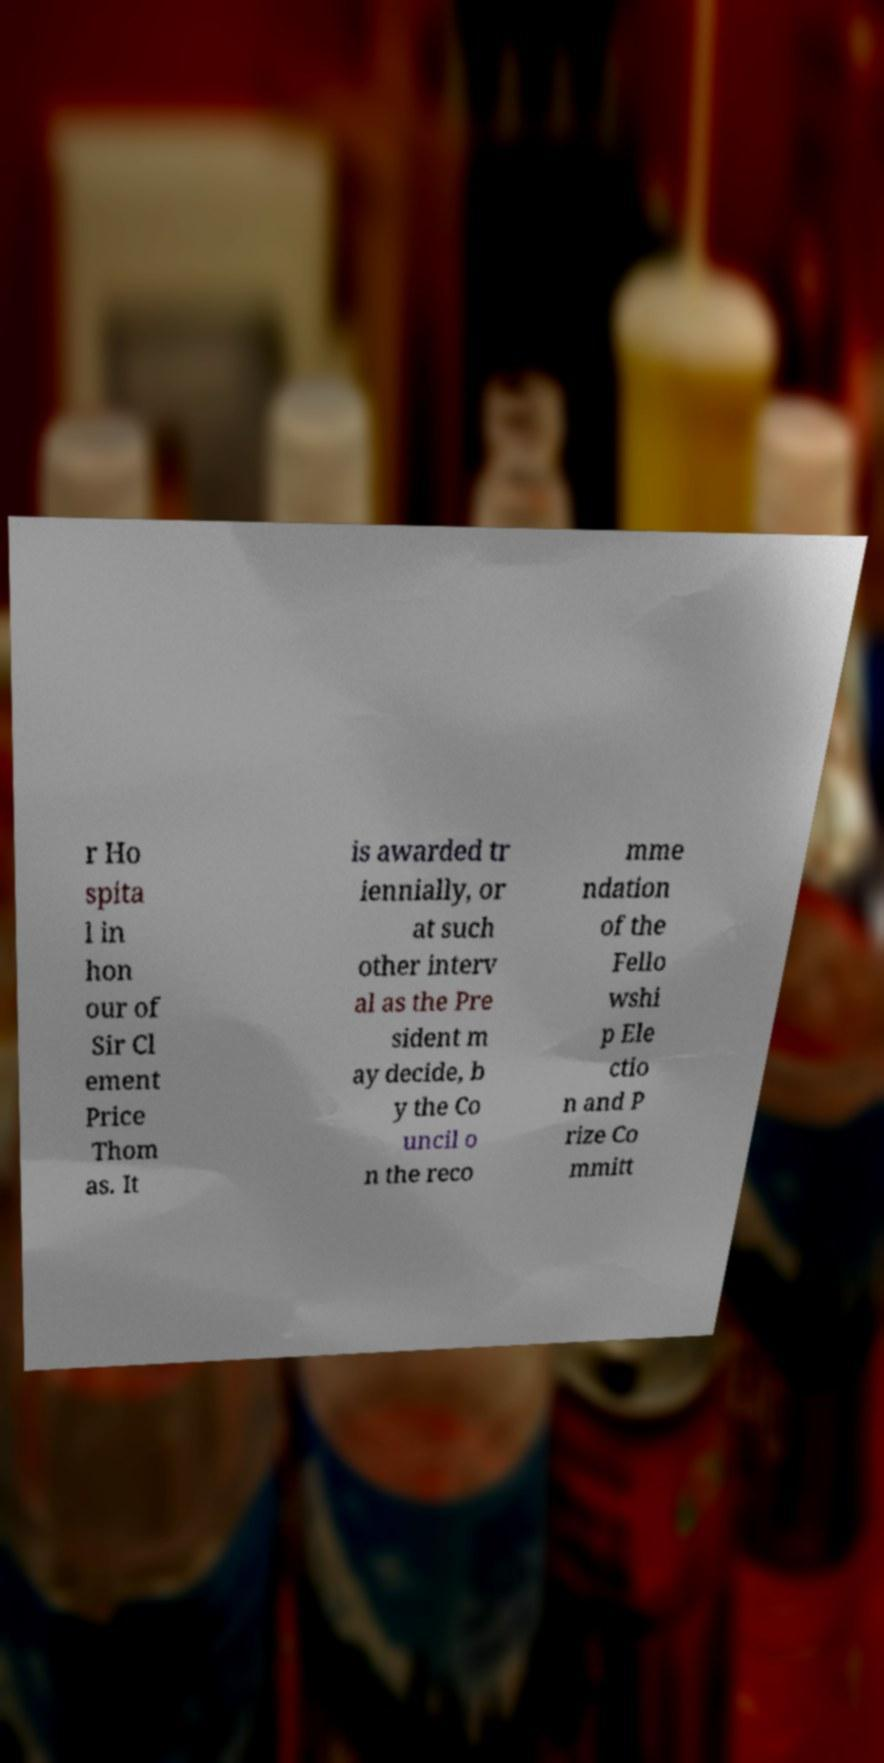Can you read and provide the text displayed in the image?This photo seems to have some interesting text. Can you extract and type it out for me? r Ho spita l in hon our of Sir Cl ement Price Thom as. It is awarded tr iennially, or at such other interv al as the Pre sident m ay decide, b y the Co uncil o n the reco mme ndation of the Fello wshi p Ele ctio n and P rize Co mmitt 